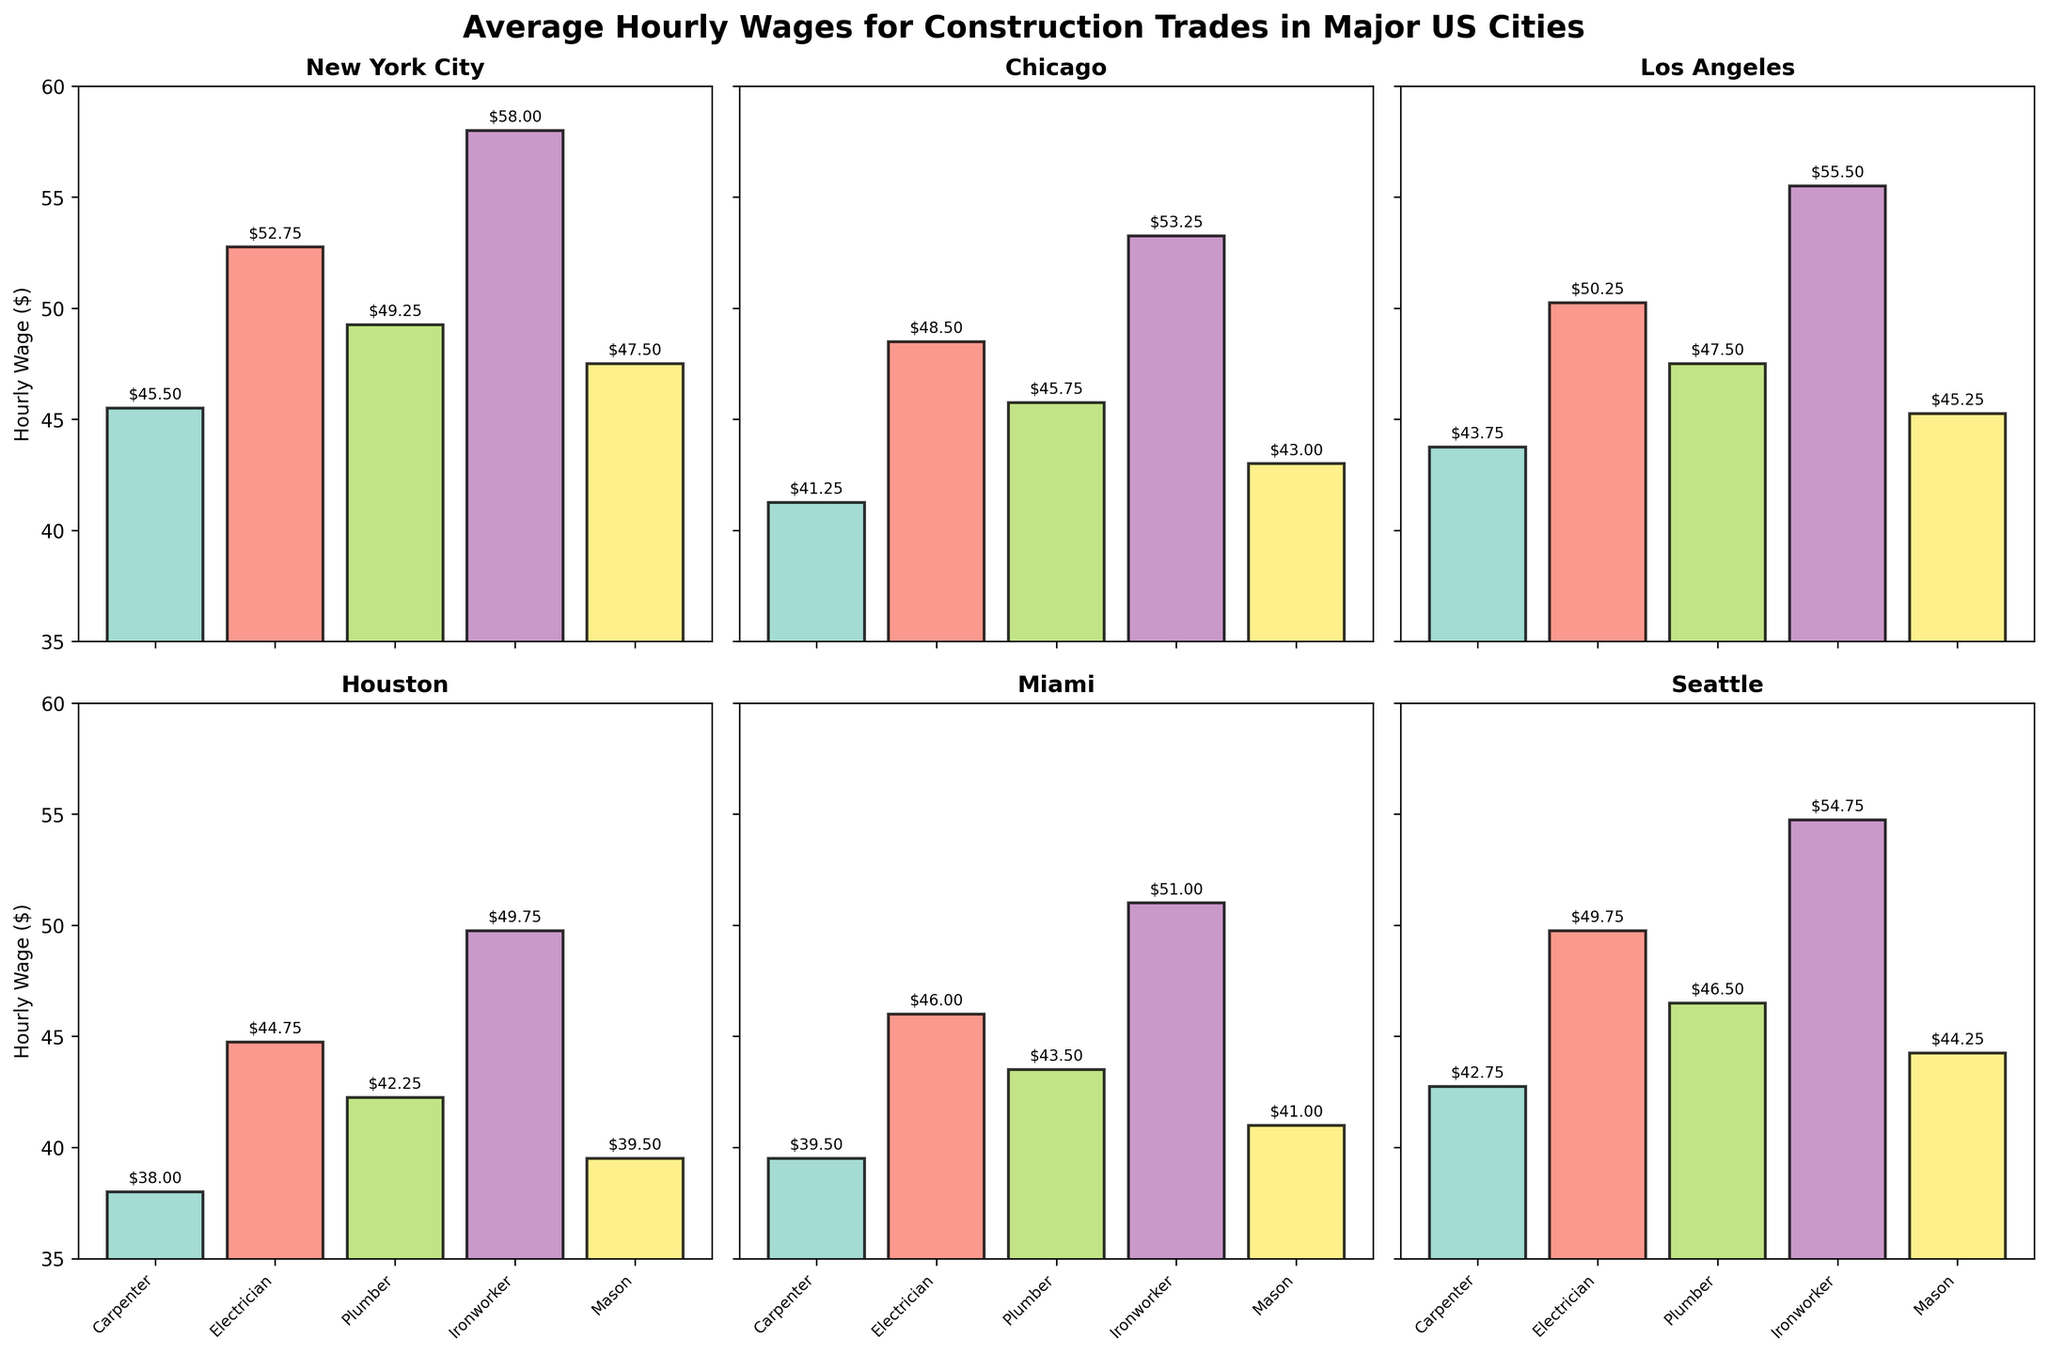Which city has the highest hourly wage for Ironworkers? By examining the subplot for Ironworkers, we can identify the bar with the highest value. New York City has an Ironworker wage of $58.00.
Answer: New York City How many cities are included in the figure? Each subplot represents a different city, and there are 6 individual subplots. Therefore, there are 6 cities included.
Answer: 6 What's the average hourly wage of Plumbers in New York City and Chicago? Add the wages for Plumbers in New York City ($49.25) and Chicago ($45.75), then divide by 2 to find the average: (49.25 + 45.75) / 2 = 47.50.
Answer: 47.50 Which trade earns more on average in Miami, Carpenters or Masons? Compare the heights of the bars for Carpenters ($39.50) and Masons ($41.00) in the Miami subplot. The Mason bar is higher.
Answer: Masons What is the title of the figure? The title is written at the top of the figure. It reads "Average Hourly Wages for Construction Trades in Major US Cities".
Answer: Average Hourly Wages for Construction Trades in Major US Cities In which city are the hourly wages for all trades closest to each other? By comparing the ranges (maximum wage minus minimum wage) within each subplot, Seattle has the smallest range: 54.75 - 42.75 = 12.00.
Answer: Seattle How much more does an Electrician earn compared to a Carpenter in Houston? Subtract the hourly wage of Carpenters ($38.00) from the hourly wage of Electricians ($44.75) in Houston: 44.75 - 38.00 = 6.75.
Answer: 6.75 Rank the cities from highest to lowest average hourly wage for all trades combined. Calculate the average hourly wage for each city by adding the wages of all trades and dividing by 5. 
1. New York City: (45.50 + 52.75 + 49.25 + 58.00 + 47.50) / 5 = 50.60
2. Los Angeles: (43.75 + 50.25 + 47.50 + 55.50 + 45.25) / 5 = 48.45
3. Chicago: (41.25 + 48.50 + 45.75 + 53.25 + 43.00) / 5 = 46.35
4. Seattle: (42.75 + 49.75 + 46.50 + 54.75 + 44.25) / 5 = 47.20
5. Miami: (39.50 + 46.00 + 43.50 + 51.00 + 41.00) / 5 = 44.20
6. Houston: (38.00 + 44.75 + 42.25 + 49.75 + 39.50) / 5 = 42.45. 
Order: New York City, Los Angeles, Seattle, Chicago, Miami, Houston
Answer: New York City, Los Angeles, Seattle, Chicago, Miami, Houston 